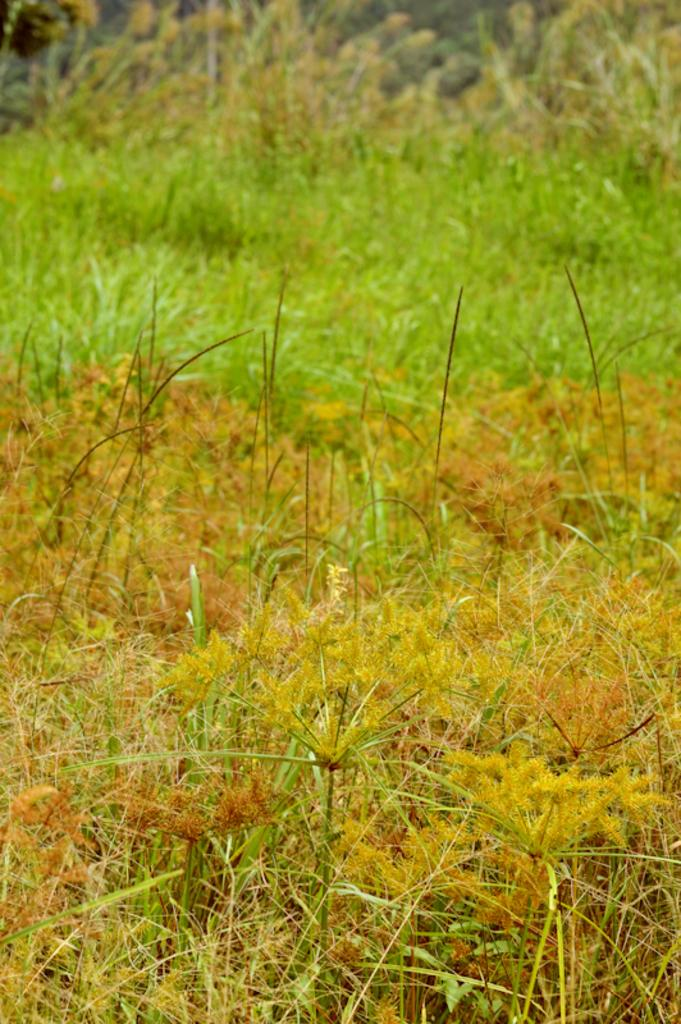What is the main feature of the foreground in the image? There are two colors of grass in the foreground of the image. How many houses are visible in the image? There are no houses visible in the image; it only features two colors of grass in the foreground. Which direction is the image facing, north or south? The image does not provide any information about the direction it is facing, so it cannot be determined whether it is facing north or south. 